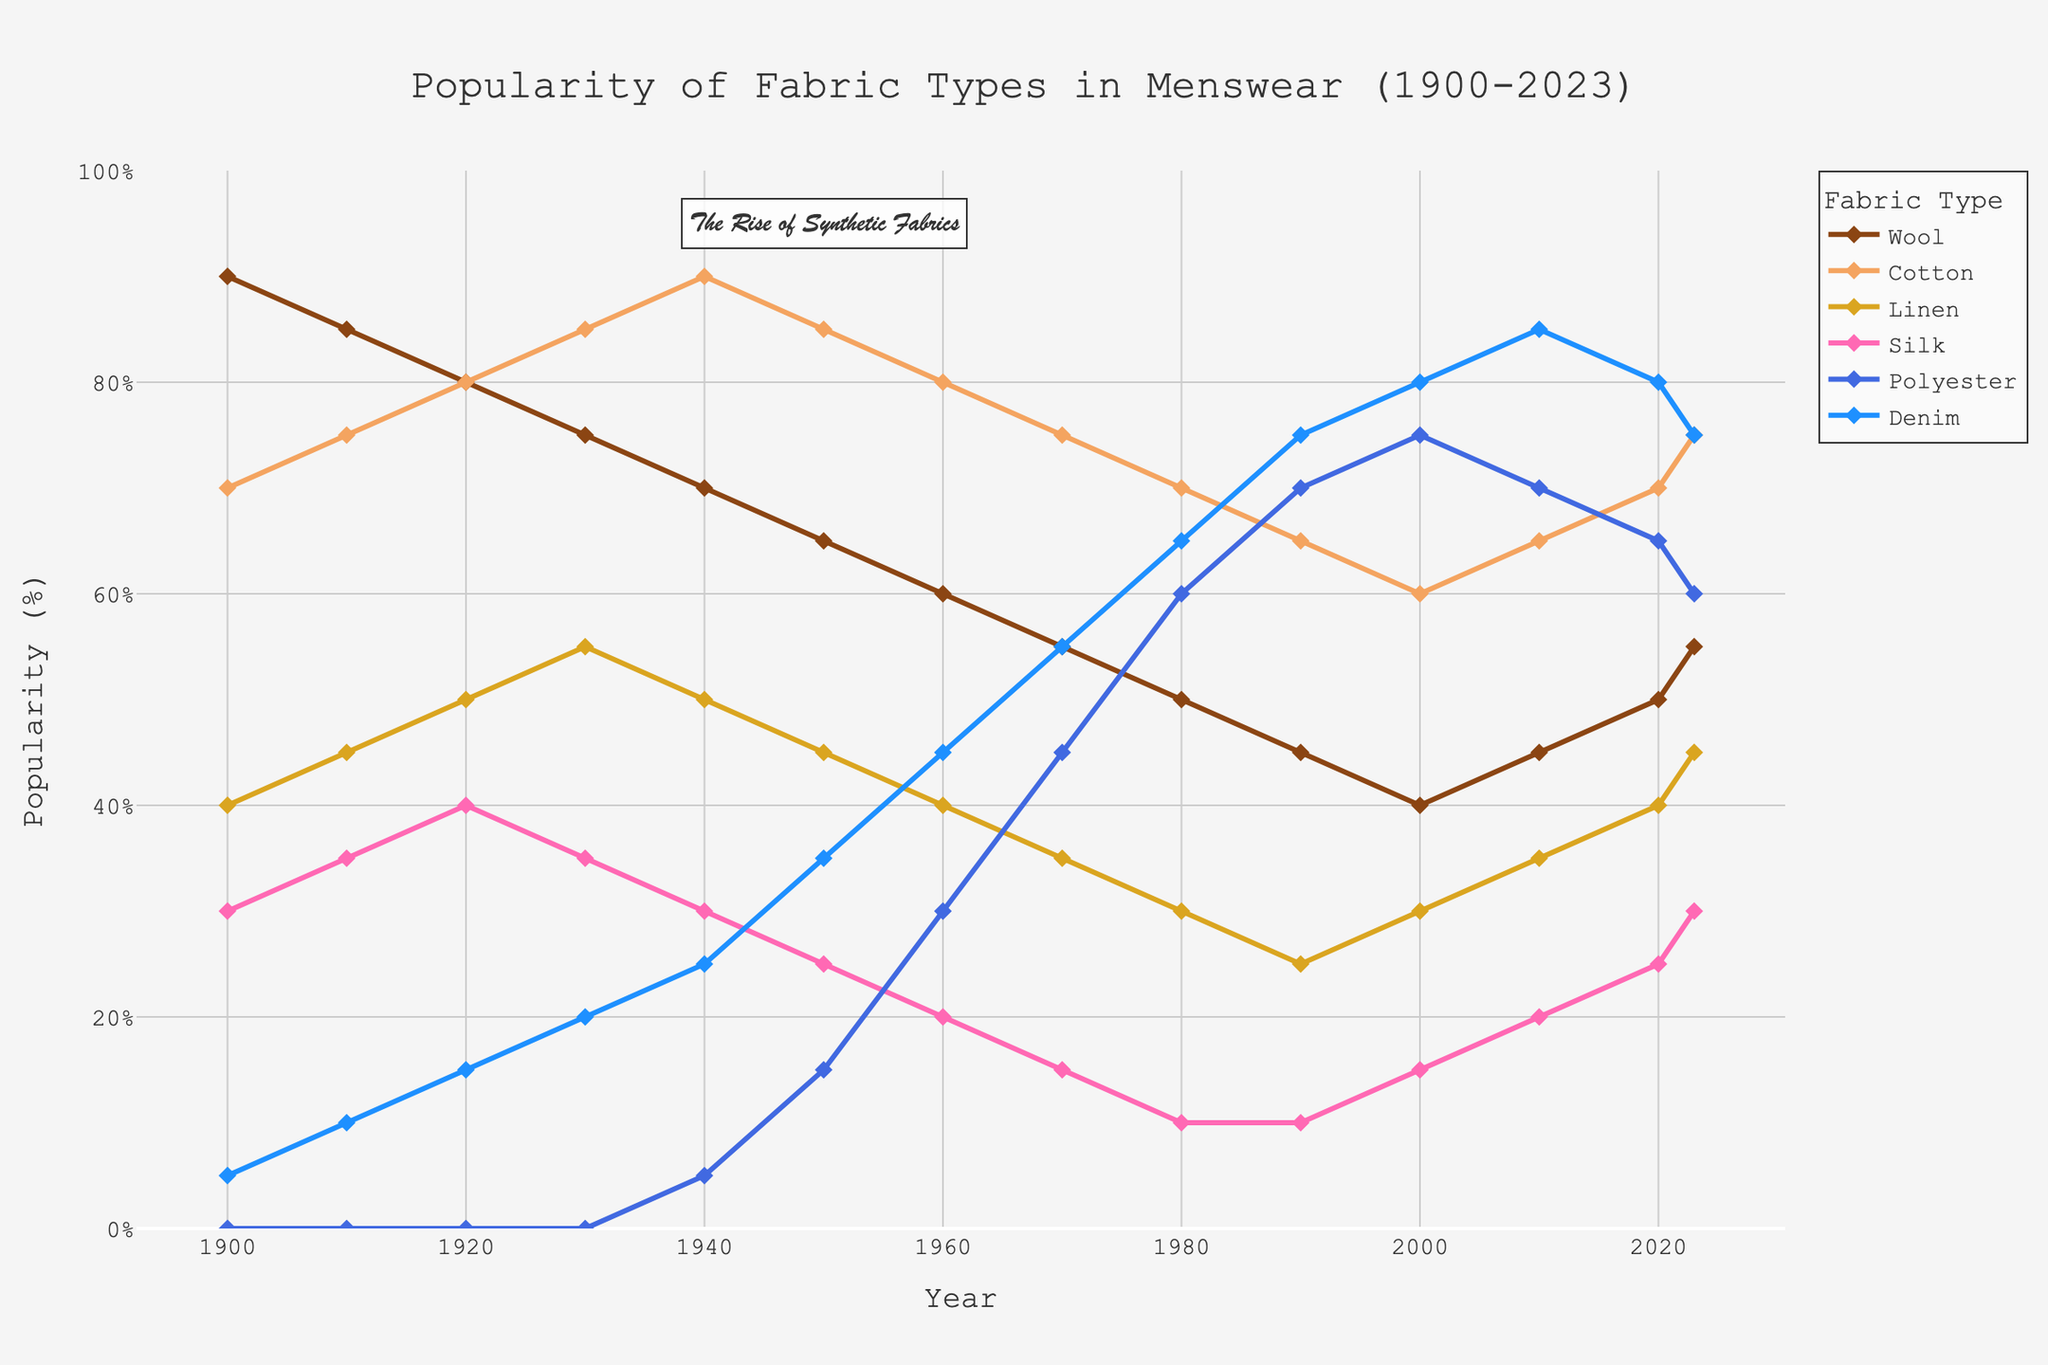What fabric type experienced the biggest drop in popularity from 1900 to 2023? To determine this, calculate the difference in popularity for each fabric type between 1900 and 2023: Wool: 90 - 55 = 35, Cotton: 70 - 75 = -5, Linen: 40 - 45 = -5, Silk: 30 - 30 = 0, Polyester: 0 - 60 = -60, Denim: 5 - 75 = -70. The biggest drop is observed in Wool which decreased by 35.
Answer: Wool Which fabric type had the highest popularity in the 1970s? Refer to the data points for 1970 in the figure. Wool: 55, Cotton: 75, Linen: 35, Silk: 15, Polyester: 45, Denim: 55. The highest value is for Cotton at 75.
Answer: Cotton Between which two decades did Polyester see the most significant increase in popularity? Compare the differenc between Polyester values across consecutive decades. The most significant increase is from the 1960s to the 1970s (30 to 45), which increased by 15.
Answer: 1960s and 1970s At what year did Denim's popularity first surpass that of Linen? Track the data for both Denim and Linen; find the first year where Denim's value exceeds Linen's. This occurs in 1940 where Denim's value (25) surpasses Linen's value (20).
Answer: 1940 Which fabric type had the most stable (least fluctuating) popularity from 1900 to 2023? Calculate the range (difference between max and min) for each fabric: 
Wool: 90-40=50, 
Cotton: 90-60=30, 
Linen: 55-25=30, 
Silk: 40-10=30, 
Polyester: 75-0=75, 
Denim: 85-5=80. 
Linen, Cotton, and Silk all have the smallest range of 30, showing the most stable popularity.
Answer: Linen, Cotton, Silk What was the average popularity of Silk in the decade of the 1980s? Add the values for Silk in 1980 (10) and 1990 (10) and divide by 2. The sum is 20 and the average is 20 / 2 = 10.
Answer: 10 Which fabric type showed a sudden increase in popularity around the 1950s? Examine the popularity trends around the 1950s. A noticeable increase is seen for Polyester, which increased from 0 in 1940 to 15 in 1950.
Answer: Polyester From 1900 to 2023, which fabric had shown the overall highest peak in popularity, and in which year did it occur? Look at the highest peaks in the graph; Cotton reaches 90 in 1940.
Answer: Cotton, 1940 